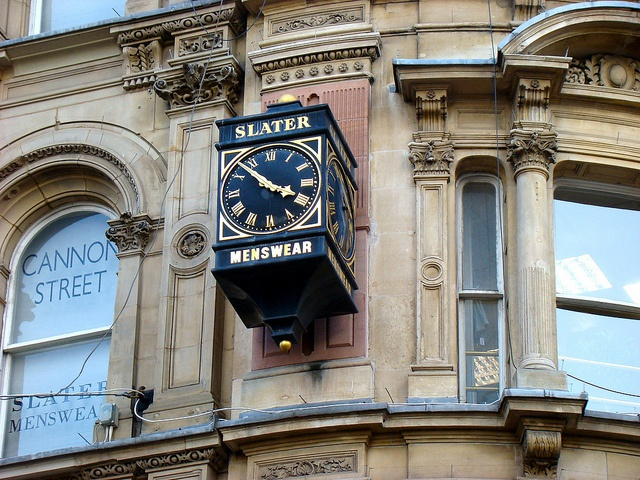Describe the objects in this image and their specific colors. I can see clock in darkgray, navy, black, blue, and ivory tones and clock in darkgray, black, gray, navy, and tan tones in this image. 